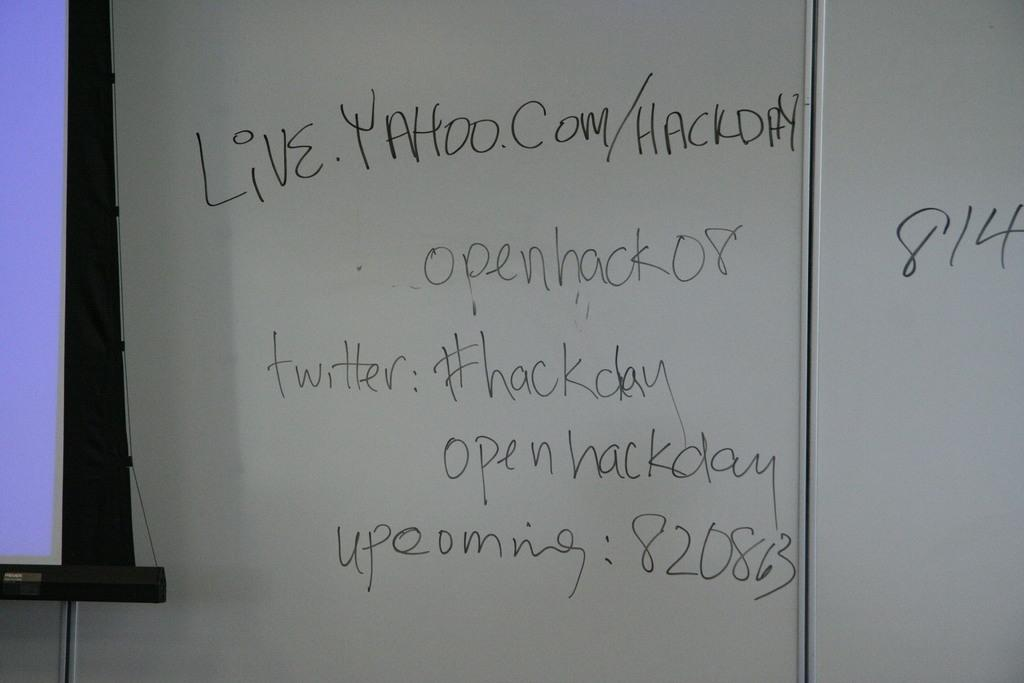Provide a one-sentence caption for the provided image. A white board has some urls and twitter hash tags written on it. 